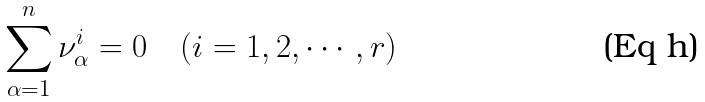<formula> <loc_0><loc_0><loc_500><loc_500>\sum _ { \alpha = 1 } ^ { n } \nu ^ { i } _ { \alpha } = 0 \quad ( i = 1 , 2 , \cdots , r )</formula> 